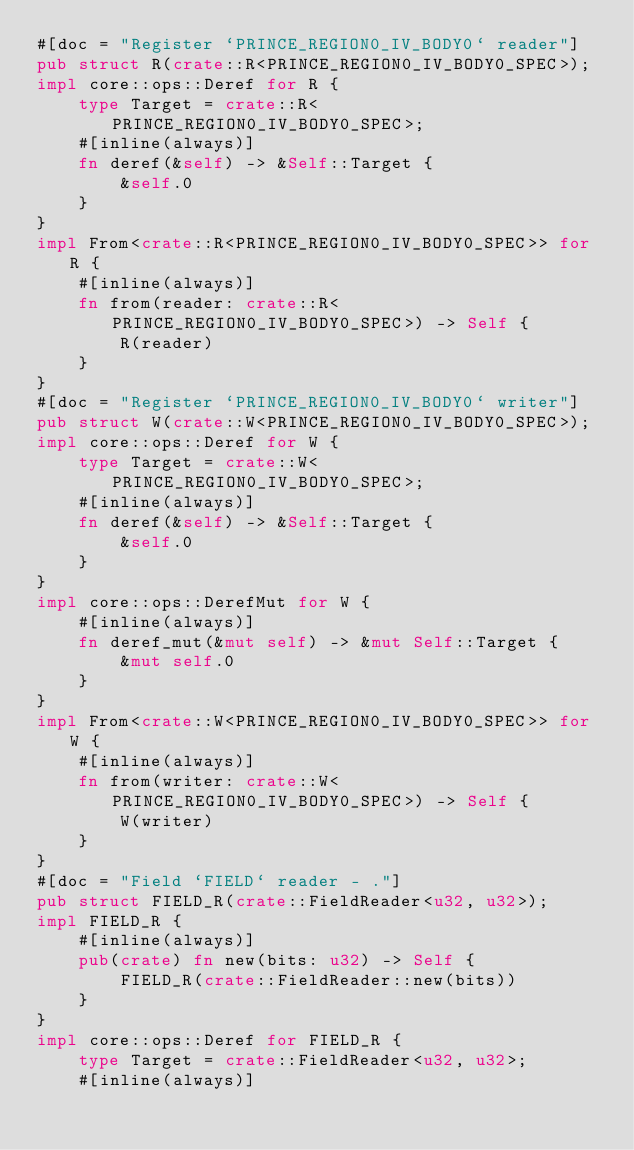Convert code to text. <code><loc_0><loc_0><loc_500><loc_500><_Rust_>#[doc = "Register `PRINCE_REGION0_IV_BODY0` reader"]
pub struct R(crate::R<PRINCE_REGION0_IV_BODY0_SPEC>);
impl core::ops::Deref for R {
    type Target = crate::R<PRINCE_REGION0_IV_BODY0_SPEC>;
    #[inline(always)]
    fn deref(&self) -> &Self::Target {
        &self.0
    }
}
impl From<crate::R<PRINCE_REGION0_IV_BODY0_SPEC>> for R {
    #[inline(always)]
    fn from(reader: crate::R<PRINCE_REGION0_IV_BODY0_SPEC>) -> Self {
        R(reader)
    }
}
#[doc = "Register `PRINCE_REGION0_IV_BODY0` writer"]
pub struct W(crate::W<PRINCE_REGION0_IV_BODY0_SPEC>);
impl core::ops::Deref for W {
    type Target = crate::W<PRINCE_REGION0_IV_BODY0_SPEC>;
    #[inline(always)]
    fn deref(&self) -> &Self::Target {
        &self.0
    }
}
impl core::ops::DerefMut for W {
    #[inline(always)]
    fn deref_mut(&mut self) -> &mut Self::Target {
        &mut self.0
    }
}
impl From<crate::W<PRINCE_REGION0_IV_BODY0_SPEC>> for W {
    #[inline(always)]
    fn from(writer: crate::W<PRINCE_REGION0_IV_BODY0_SPEC>) -> Self {
        W(writer)
    }
}
#[doc = "Field `FIELD` reader - ."]
pub struct FIELD_R(crate::FieldReader<u32, u32>);
impl FIELD_R {
    #[inline(always)]
    pub(crate) fn new(bits: u32) -> Self {
        FIELD_R(crate::FieldReader::new(bits))
    }
}
impl core::ops::Deref for FIELD_R {
    type Target = crate::FieldReader<u32, u32>;
    #[inline(always)]</code> 